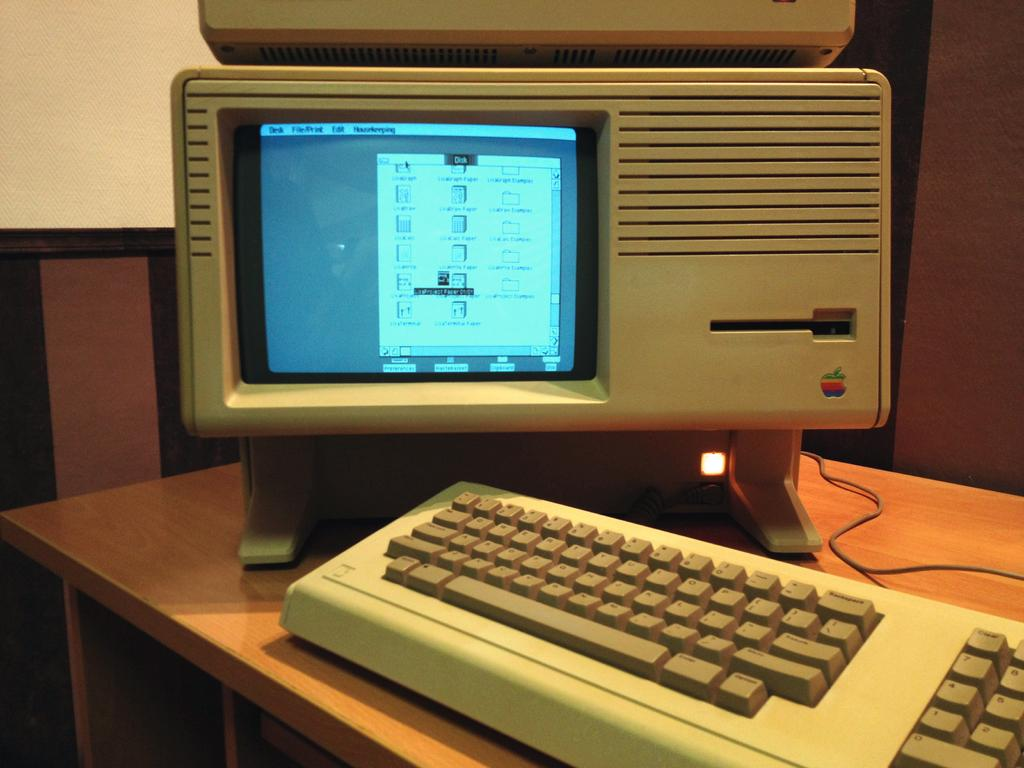What piece of furniture is in the image? There is a table in the image. What electronic devices are on the table? A keyboard and a monitor are on the table. Can you describe any visible connections in the image? There is a wire visible in the image. What can be seen in the background of the image? There is a wall in the background of the image. What type of impulse can be seen traveling through the railway in the image? There is no railway present in the image; it features a table with a keyboard and monitor. How does the home in the image contribute to the overall aesthetic? There is no home present in the image; it features a table with a keyboard and monitor. 